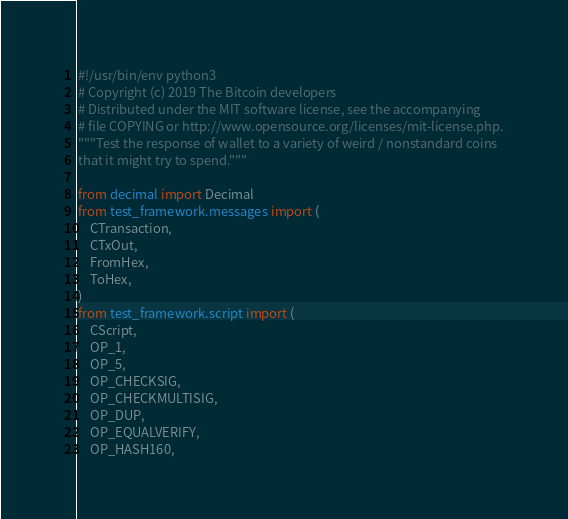Convert code to text. <code><loc_0><loc_0><loc_500><loc_500><_Python_>#!/usr/bin/env python3
# Copyright (c) 2019 The Bitcoin developers
# Distributed under the MIT software license, see the accompanying
# file COPYING or http://www.opensource.org/licenses/mit-license.php.
"""Test the response of wallet to a variety of weird / nonstandard coins
that it might try to spend."""

from decimal import Decimal
from test_framework.messages import (
    CTransaction,
    CTxOut,
    FromHex,
    ToHex,
)
from test_framework.script import (
    CScript,
    OP_1,
    OP_5,
    OP_CHECKSIG,
    OP_CHECKMULTISIG,
    OP_DUP,
    OP_EQUALVERIFY,
    OP_HASH160,</code> 